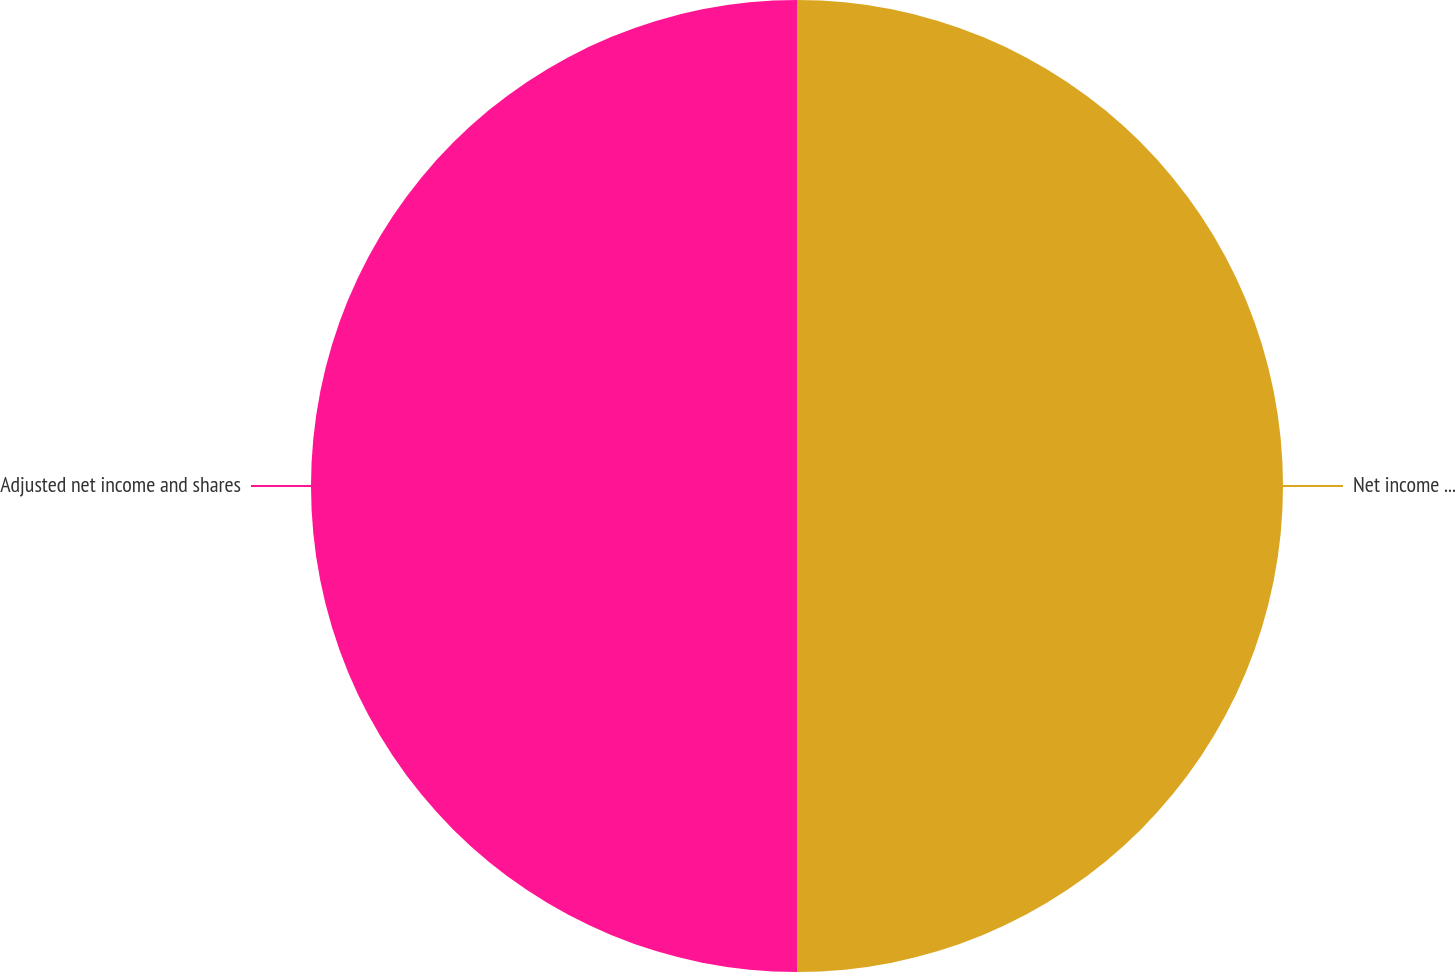Convert chart to OTSL. <chart><loc_0><loc_0><loc_500><loc_500><pie_chart><fcel>Net income available to common<fcel>Adjusted net income and shares<nl><fcel>50.0%<fcel>50.0%<nl></chart> 